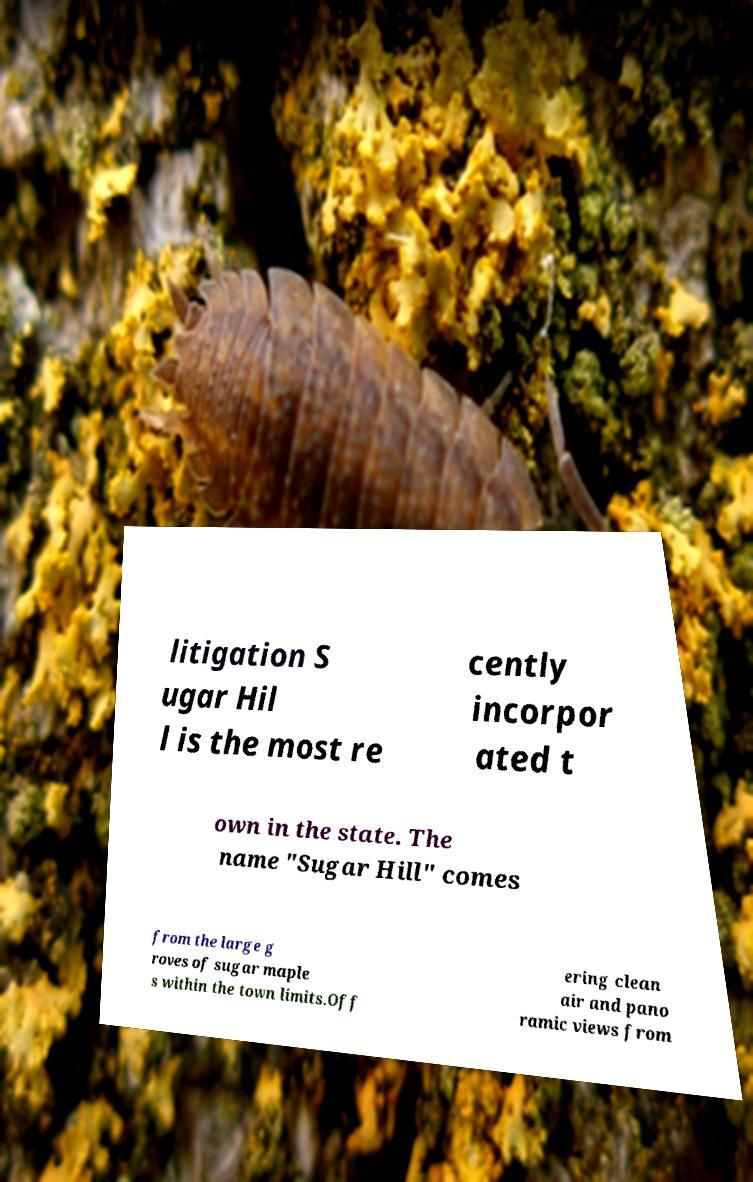For documentation purposes, I need the text within this image transcribed. Could you provide that? litigation S ugar Hil l is the most re cently incorpor ated t own in the state. The name "Sugar Hill" comes from the large g roves of sugar maple s within the town limits.Off ering clean air and pano ramic views from 